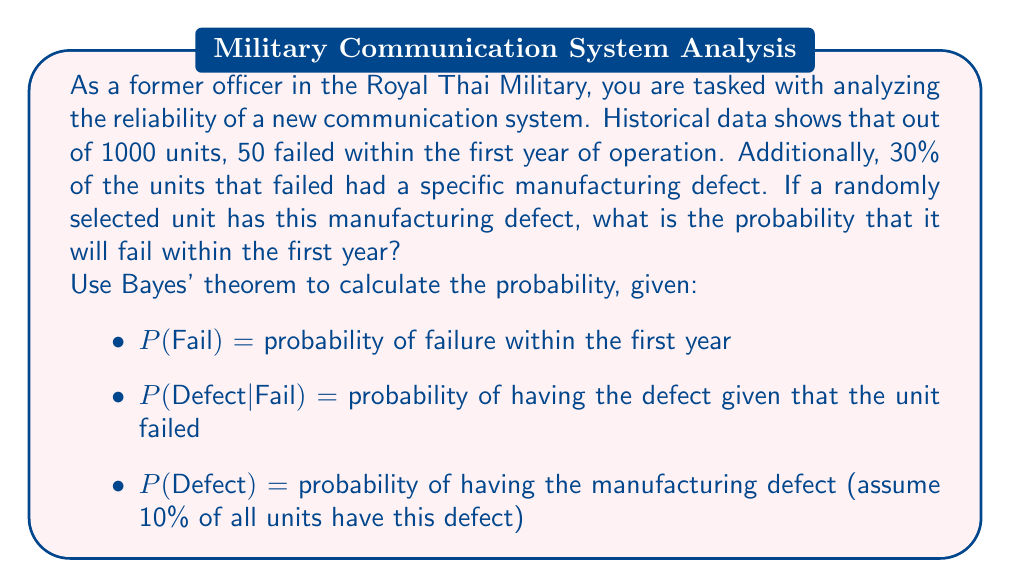Help me with this question. To solve this problem, we'll use Bayes' theorem, which is expressed as:

$$P(A|B) = \frac{P(B|A) \cdot P(A)}{P(B)}$$

Where:
- A is the event of failure within the first year
- B is the event of having the manufacturing defect

Given information:
- P(Fail) = 50/1000 = 0.05
- P(Defect|Fail) = 0.30
- P(Defect) = 0.10

We want to find P(Fail|Defect), so we'll use Bayes' theorem:

$$P(Fail|Defect) = \frac{P(Defect|Fail) \cdot P(Fail)}{P(Defect)}$$

Step 1: Substitute the known values into the formula
$$P(Fail|Defect) = \frac{0.30 \cdot 0.05}{0.10}$$

Step 2: Perform the calculation
$$P(Fail|Defect) = \frac{0.015}{0.10} = 0.15$$

Therefore, the probability that a unit with the manufacturing defect will fail within the first year is 0.15 or 15%.
Answer: The probability that a unit with the manufacturing defect will fail within the first year is 0.15 or 15%. 